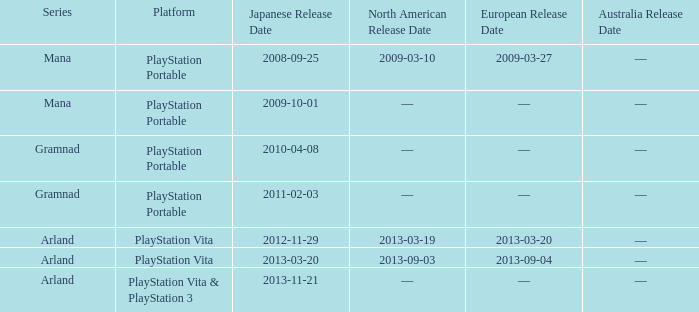What is the series with a North American release date on 2013-09-03? Arland. 